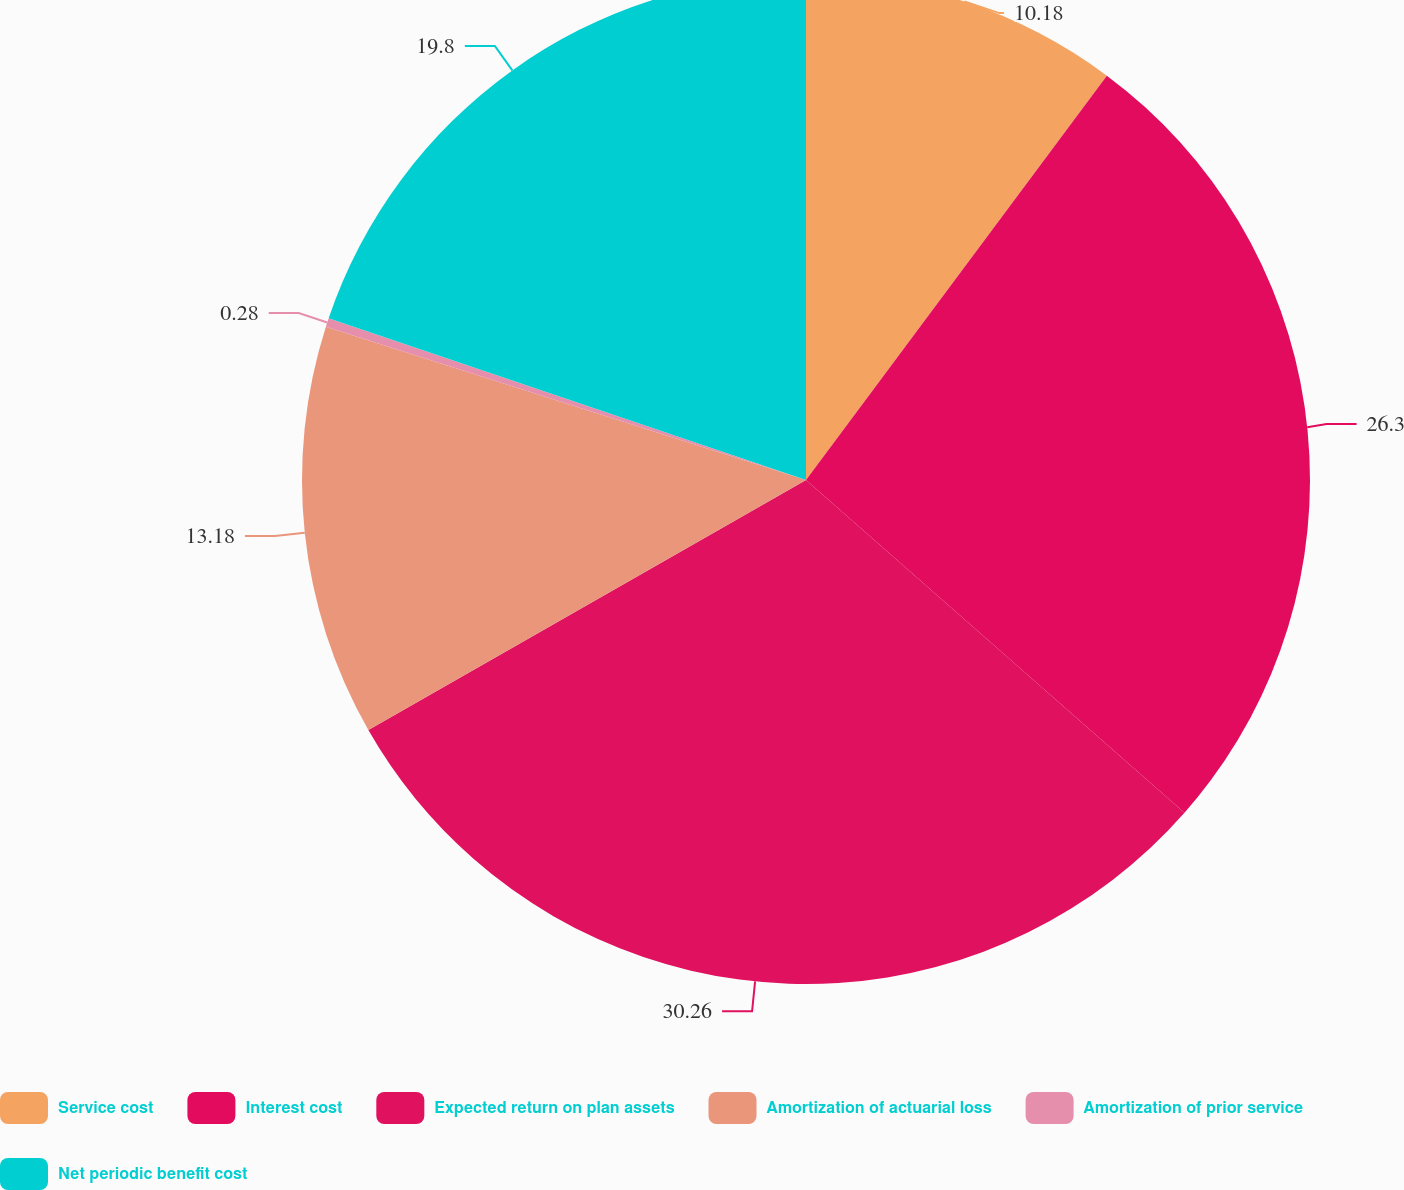<chart> <loc_0><loc_0><loc_500><loc_500><pie_chart><fcel>Service cost<fcel>Interest cost<fcel>Expected return on plan assets<fcel>Amortization of actuarial loss<fcel>Amortization of prior service<fcel>Net periodic benefit cost<nl><fcel>10.18%<fcel>26.3%<fcel>30.26%<fcel>13.18%<fcel>0.28%<fcel>19.8%<nl></chart> 